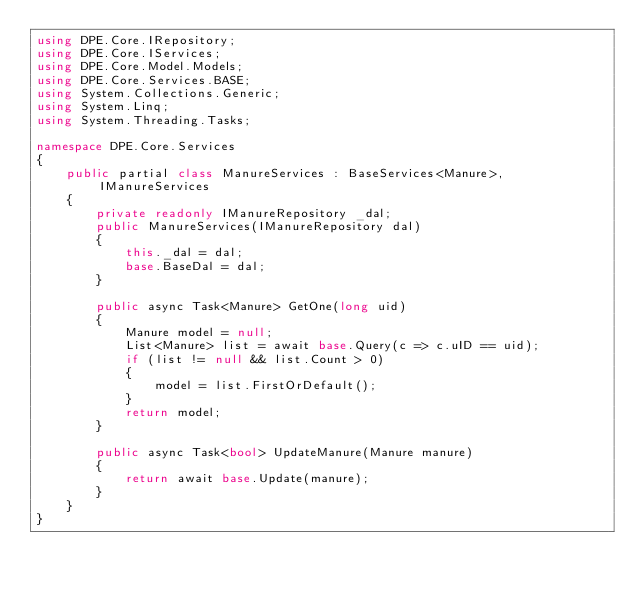Convert code to text. <code><loc_0><loc_0><loc_500><loc_500><_C#_>using DPE.Core.IRepository;
using DPE.Core.IServices;
using DPE.Core.Model.Models;
using DPE.Core.Services.BASE;
using System.Collections.Generic;
using System.Linq;
using System.Threading.Tasks;

namespace DPE.Core.Services
{
    public partial class ManureServices : BaseServices<Manure>, IManureServices
    {
        private readonly IManureRepository _dal;
        public ManureServices(IManureRepository dal)
        {
            this._dal = dal;
            base.BaseDal = dal;
        }

        public async Task<Manure> GetOne(long uid)
        {
            Manure model = null;
            List<Manure> list = await base.Query(c => c.uID == uid);
            if (list != null && list.Count > 0)
            {
                model = list.FirstOrDefault();
            }
            return model;
        }

        public async Task<bool> UpdateManure(Manure manure)
        {
            return await base.Update(manure);
        }
    }
}</code> 